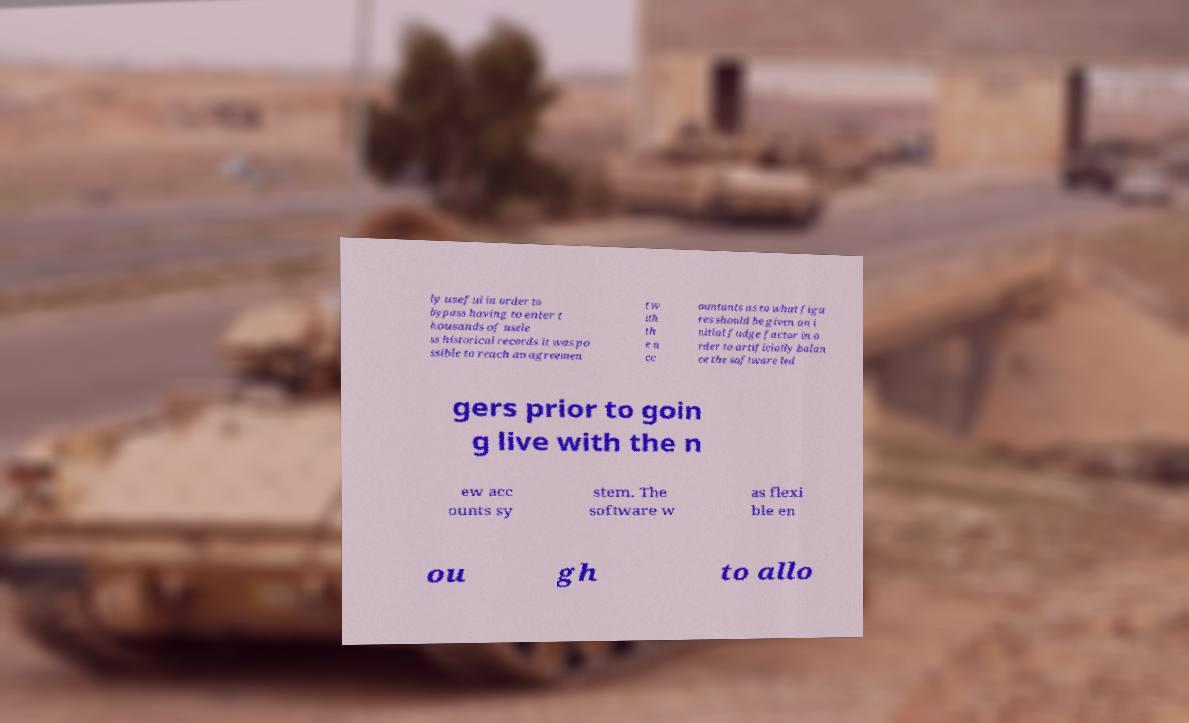I need the written content from this picture converted into text. Can you do that? ly useful in order to bypass having to enter t housands of usele ss historical records it was po ssible to reach an agreemen t w ith th e a cc ountants as to what figu res should be given an i nitial fudge factor in o rder to artificially balan ce the software led gers prior to goin g live with the n ew acc ounts sy stem. The software w as flexi ble en ou gh to allo 